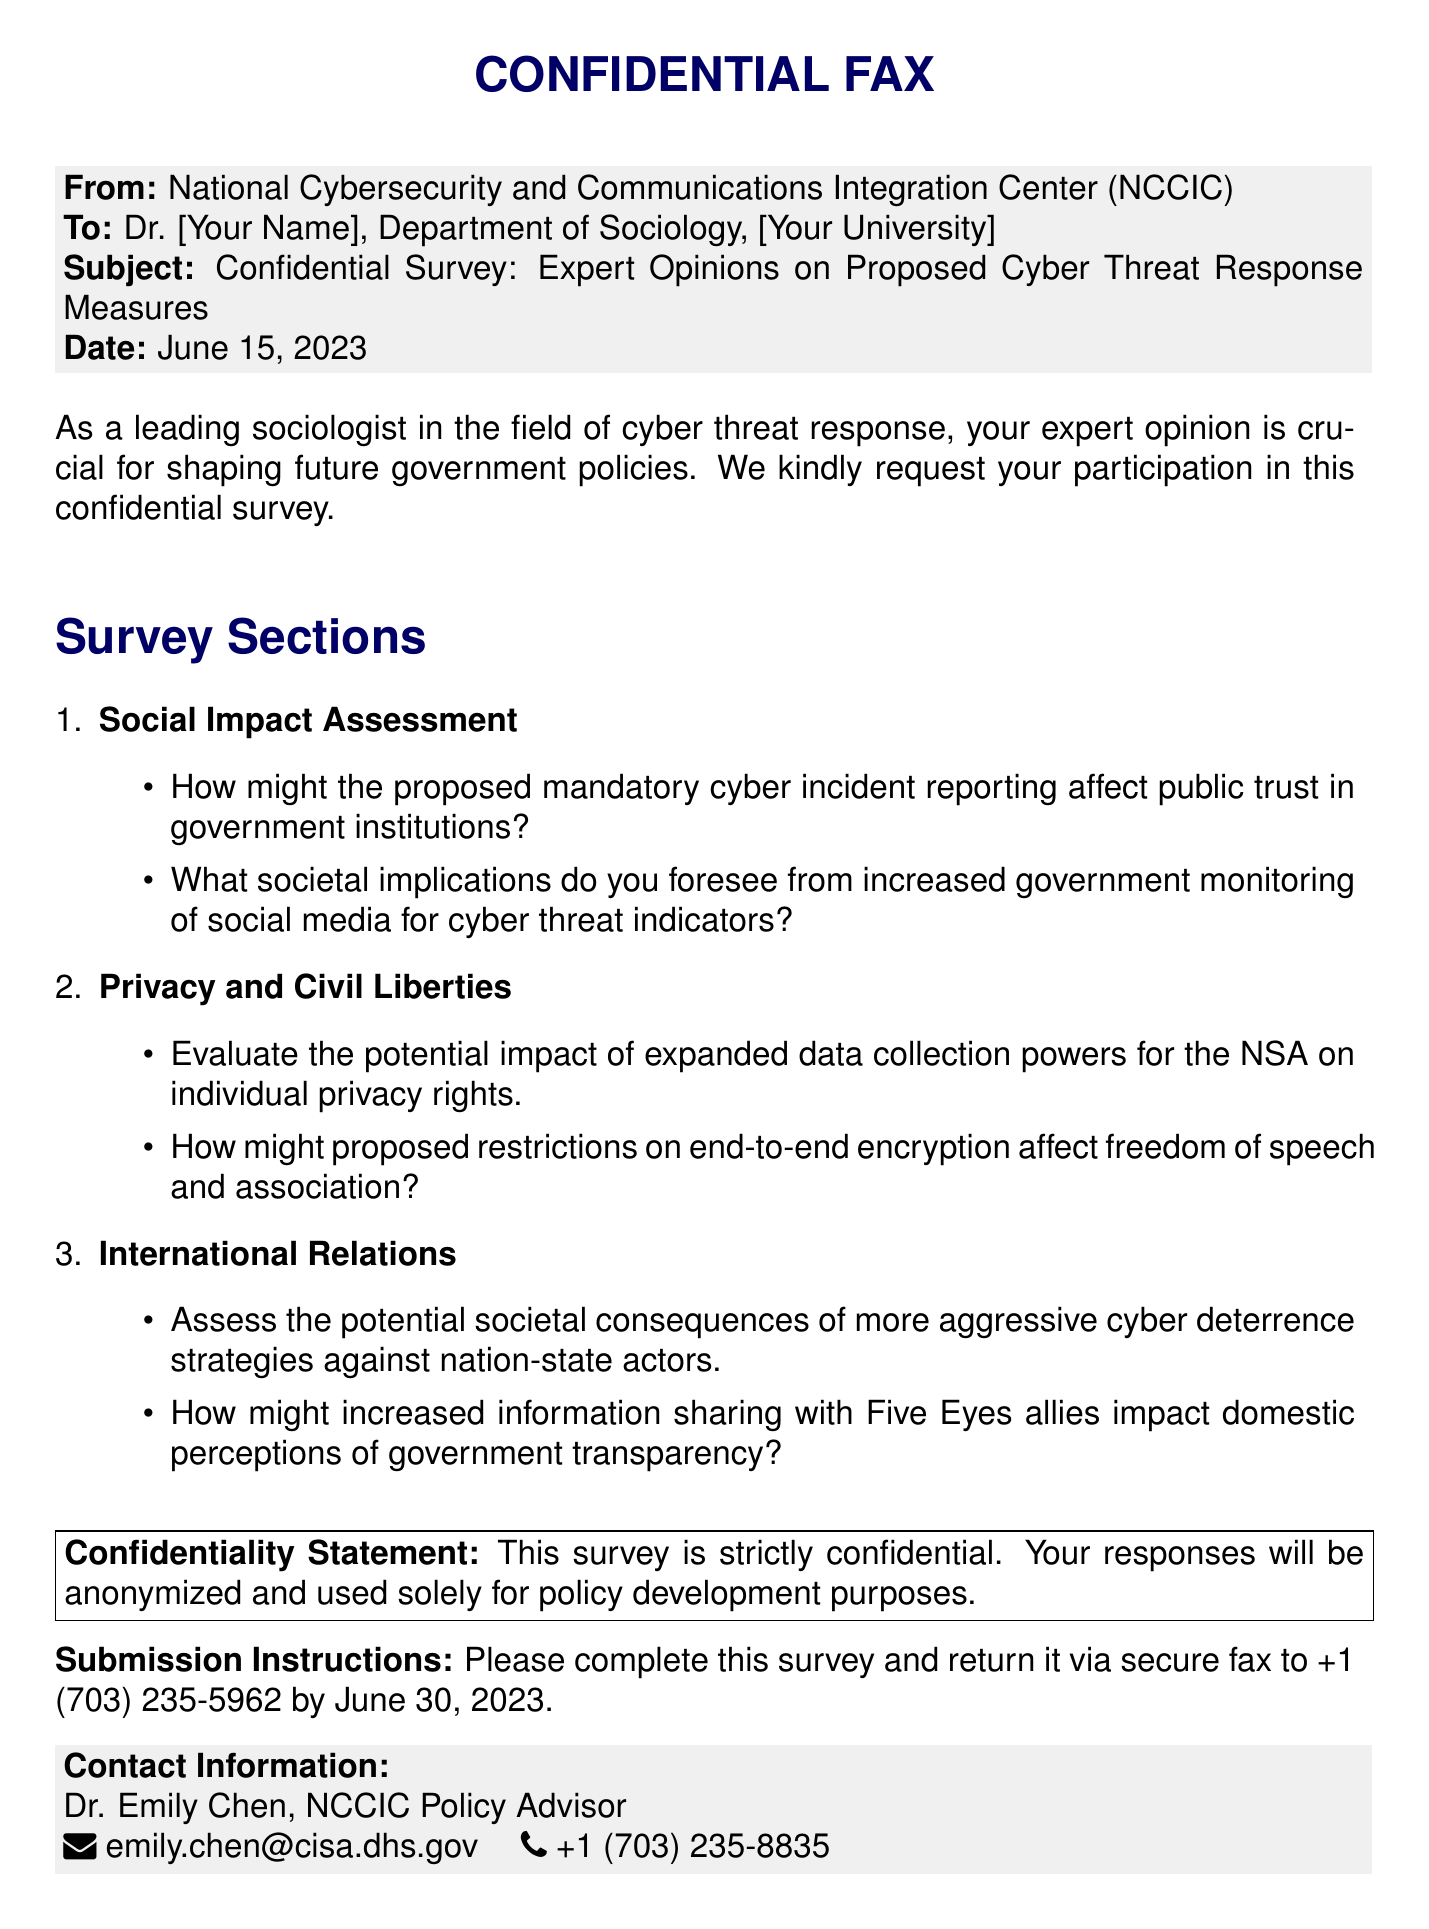what is the date of the fax? The date at the top of the document indicates when it was sent, which is June 15, 2023.
Answer: June 15, 2023 who is the sender of the fax? The sender of the fax is identified in the 'From' section of the document, which is the National Cybersecurity and Communications Integration Center (NCCIC).
Answer: National Cybersecurity and Communications Integration Center (NCCIC) what is the main purpose of the survey? The purpose of the survey is mentioned in the introductory paragraph inviting expert opinions on proposed cyber threat response measures.
Answer: Expert opinions on proposed cyber threat response measures what is the submission deadline for the survey? The submission deadline is provided towards the end of the document, specifying when responses should be returned.
Answer: June 30, 2023 what is the method of return for the survey? The return method is explicitly mentioned in the submission instructions section, indicating how the completed surveys should be sent back.
Answer: Secure fax how many sections are in the survey? The document lists survey sections and counts them, which can be determined from the enumeration at the beginning of the survey sections.
Answer: Three what potential impact does the document mention regarding monitoring social media? The document outlines societal implications related to increased government monitoring for cyber threat indicators.
Answer: Increased government monitoring of social media for cyber threat indicators who should be contacted for more information about the survey? The 'Contact Information' section provides details on who to reach out to for additional inquiries regarding the survey.
Answer: Dr. Emily Chen 